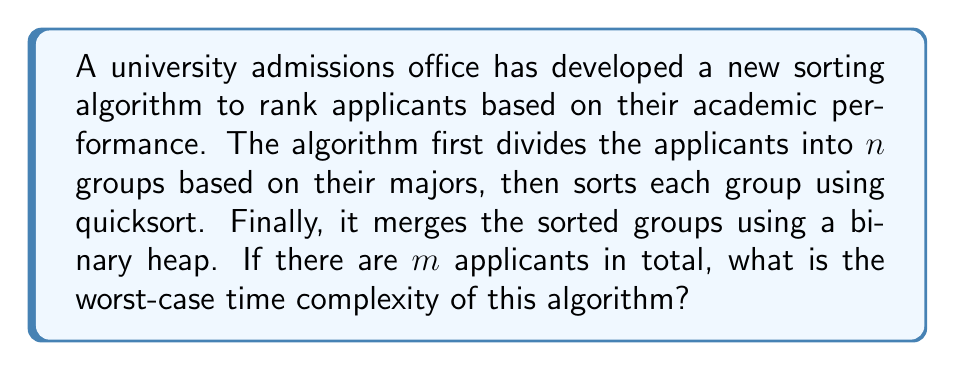What is the answer to this math problem? Let's break down the algorithm and analyze its components:

1. Dividing applicants into groups:
   This step requires iterating through all $m$ applicants once, so its time complexity is $O(m)$.

2. Sorting each group using quicksort:
   - Worst-case time complexity of quicksort: $O(k^2)$ for $k$ elements
   - There are $n$ groups, and in the worst case, all applicants could be in one group
   - So, the worst-case time complexity for this step is $O(m^2)$

3. Merging sorted groups using a binary heap:
   - Building a heap with $n$ elements takes $O(n)$ time
   - Extracting the minimum element and re-heapifying takes $O(\log n)$ time
   - This process is repeated $m$ times (once for each applicant)
   - So, the time complexity for this step is $O(n + m\log n)$

Combining all steps, we get:
$$O(m) + O(m^2) + O(n + m\log n)$$

Since $n \leq m$ (number of groups cannot exceed number of applicants), we can simplify this to:
$$O(m^2 + m\log m)$$

The dominant term here is $m^2$, so we can further simplify to:
$$O(m^2)$$

Therefore, the worst-case time complexity of the algorithm is $O(m^2)$, where $m$ is the total number of applicants.
Answer: $O(m^2)$, where $m$ is the total number of applicants. 